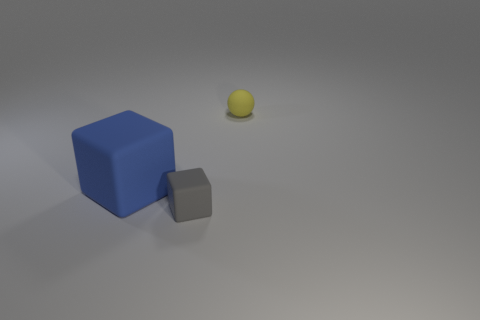Add 3 blocks. How many objects exist? 6 Subtract all balls. How many objects are left? 2 Subtract 0 cyan cubes. How many objects are left? 3 Subtract all large green metallic blocks. Subtract all small rubber things. How many objects are left? 1 Add 1 rubber spheres. How many rubber spheres are left? 2 Add 3 blue blocks. How many blue blocks exist? 4 